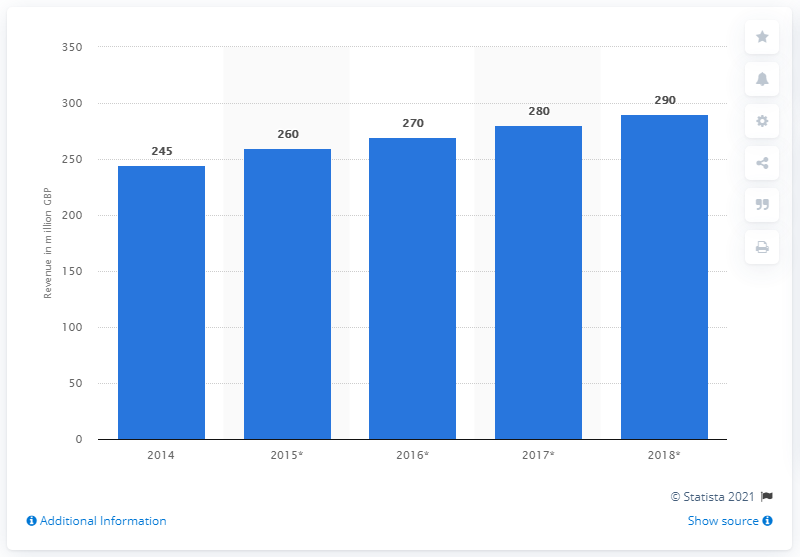What was the revenue generated in 2014? In 2014, the reported revenue was 245 million GBP, as indicated by the bar chart presented. 